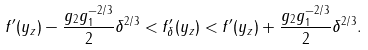<formula> <loc_0><loc_0><loc_500><loc_500>f ^ { \prime } ( y _ { z } ) - \frac { g _ { 2 } g _ { 1 } ^ { - 2 / 3 } } { 2 } \delta ^ { 2 / 3 } < f ^ { \prime } _ { \delta } ( y _ { z } ) < f ^ { \prime } ( y _ { z } ) + \frac { g _ { 2 } g _ { 1 } ^ { - 2 / 3 } } { 2 } \delta ^ { 2 / 3 } .</formula> 